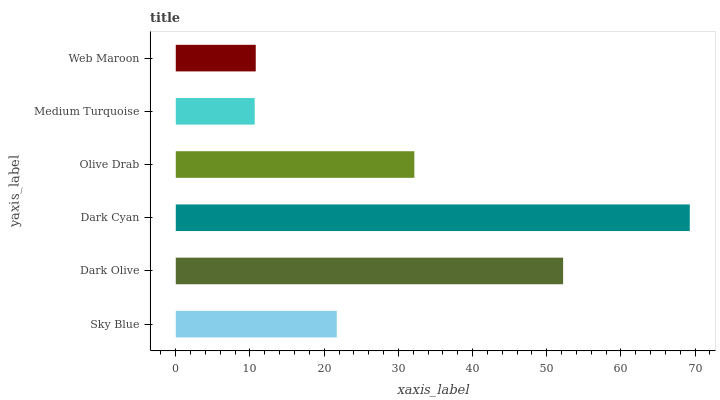Is Medium Turquoise the minimum?
Answer yes or no. Yes. Is Dark Cyan the maximum?
Answer yes or no. Yes. Is Dark Olive the minimum?
Answer yes or no. No. Is Dark Olive the maximum?
Answer yes or no. No. Is Dark Olive greater than Sky Blue?
Answer yes or no. Yes. Is Sky Blue less than Dark Olive?
Answer yes or no. Yes. Is Sky Blue greater than Dark Olive?
Answer yes or no. No. Is Dark Olive less than Sky Blue?
Answer yes or no. No. Is Olive Drab the high median?
Answer yes or no. Yes. Is Sky Blue the low median?
Answer yes or no. Yes. Is Dark Cyan the high median?
Answer yes or no. No. Is Web Maroon the low median?
Answer yes or no. No. 